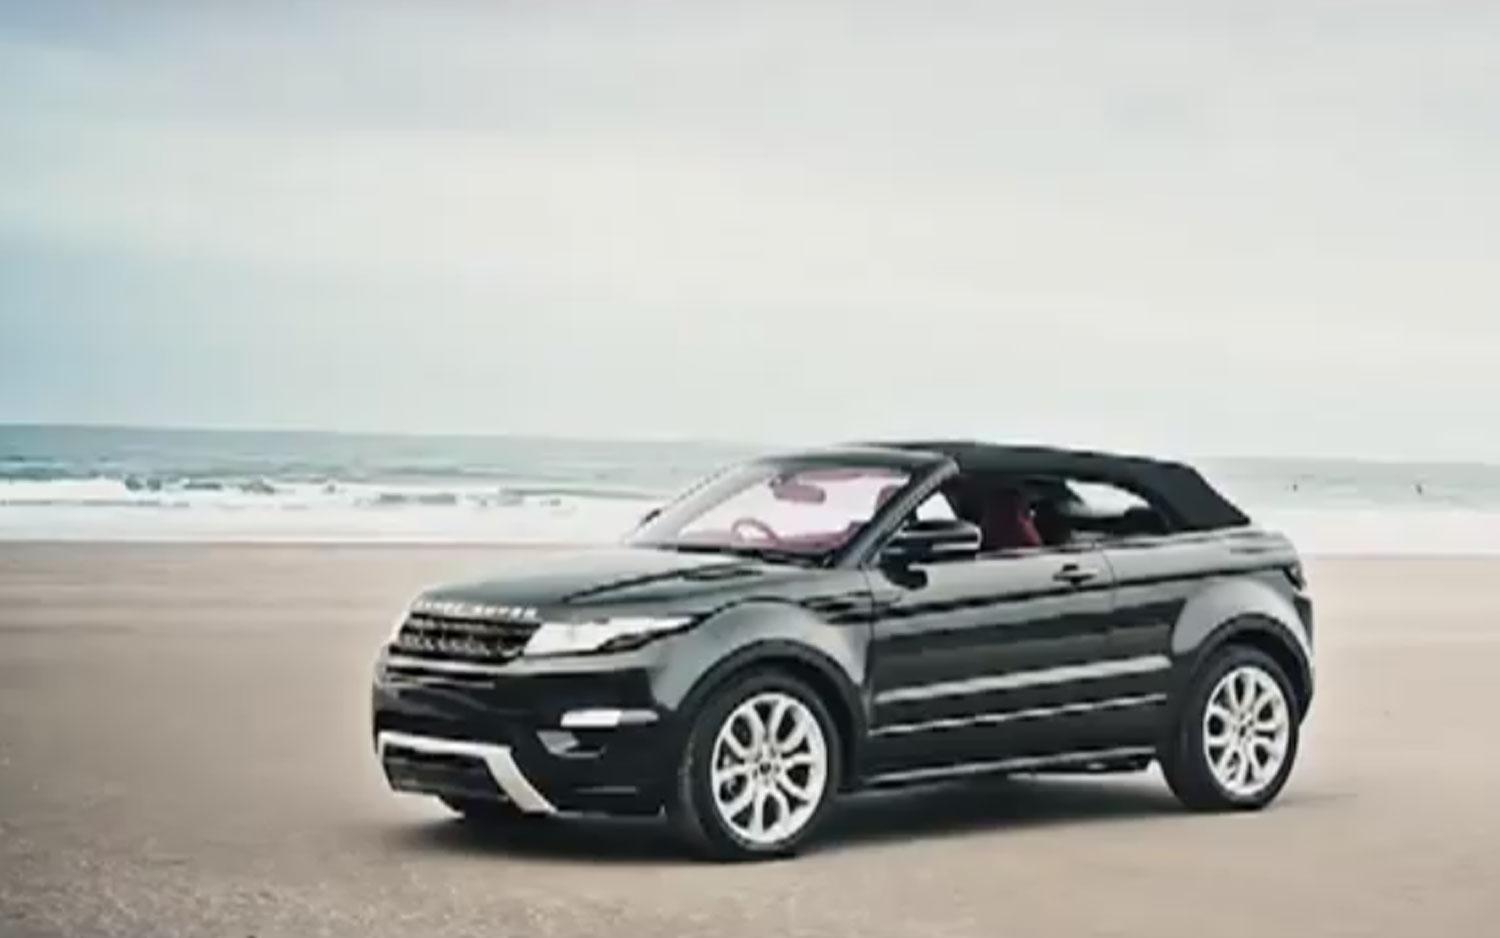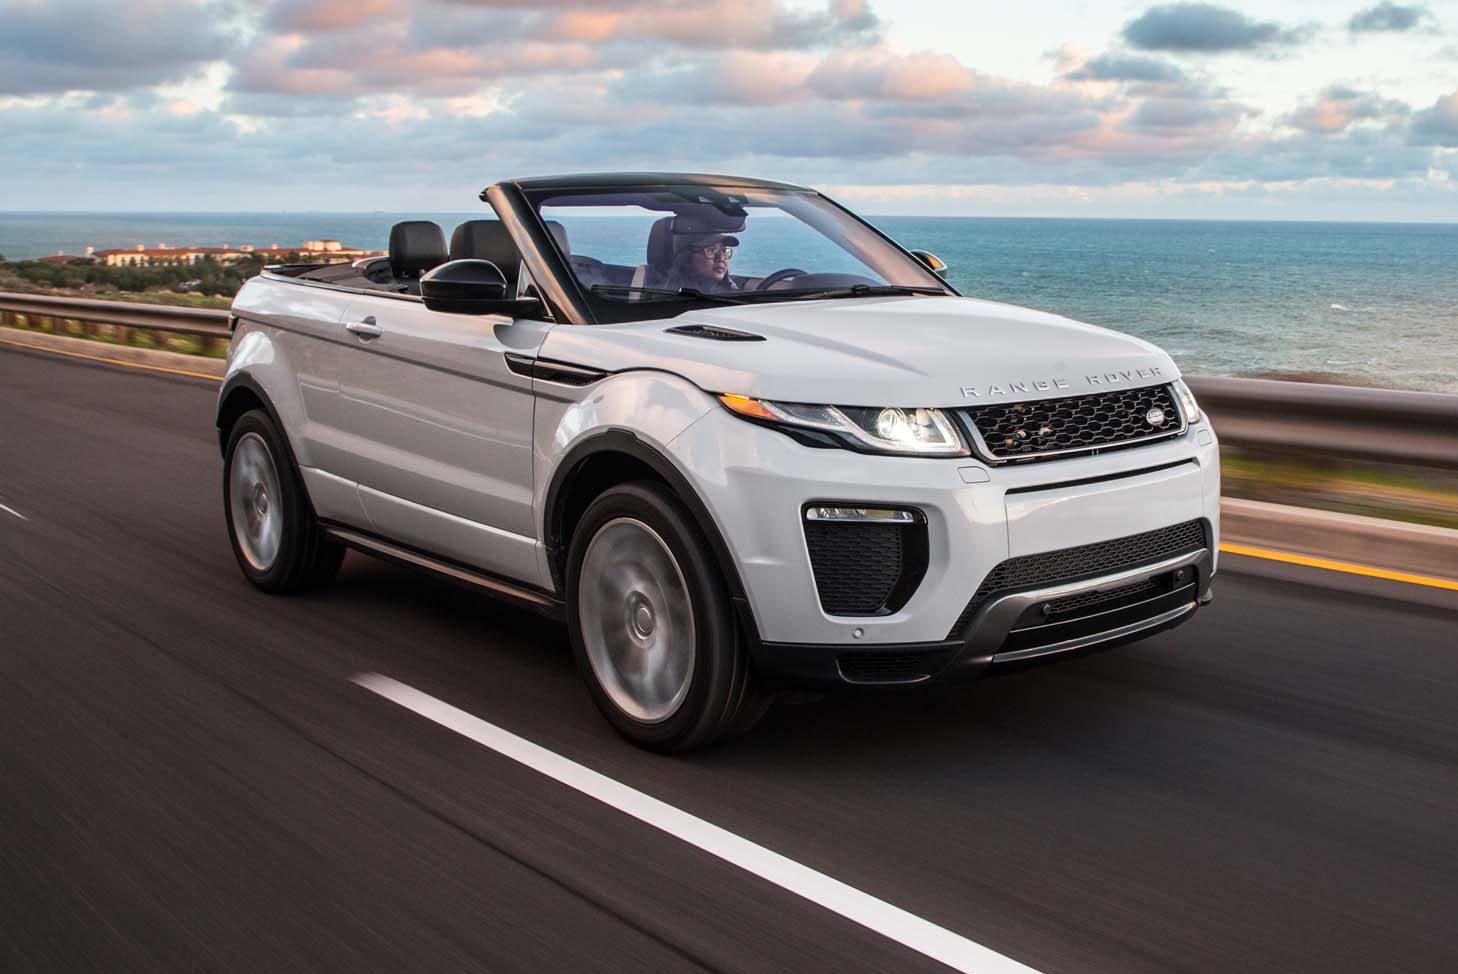The first image is the image on the left, the second image is the image on the right. Given the left and right images, does the statement "The right image features one white topless convertible parked in a marked space facing the ocean, with its rear to the camera." hold true? Answer yes or no. No. The first image is the image on the left, the second image is the image on the right. Analyze the images presented: Is the assertion "In one if the images, a car is facing the water and you can see its back licence plate." valid? Answer yes or no. No. 